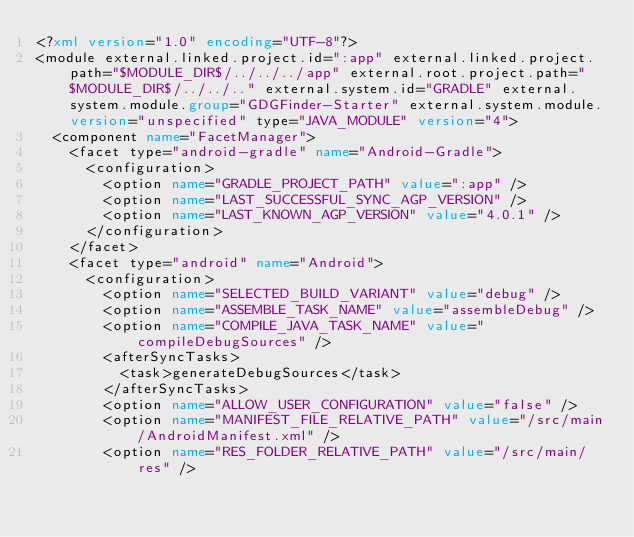<code> <loc_0><loc_0><loc_500><loc_500><_XML_><?xml version="1.0" encoding="UTF-8"?>
<module external.linked.project.id=":app" external.linked.project.path="$MODULE_DIR$/../../../app" external.root.project.path="$MODULE_DIR$/../../.." external.system.id="GRADLE" external.system.module.group="GDGFinder-Starter" external.system.module.version="unspecified" type="JAVA_MODULE" version="4">
  <component name="FacetManager">
    <facet type="android-gradle" name="Android-Gradle">
      <configuration>
        <option name="GRADLE_PROJECT_PATH" value=":app" />
        <option name="LAST_SUCCESSFUL_SYNC_AGP_VERSION" />
        <option name="LAST_KNOWN_AGP_VERSION" value="4.0.1" />
      </configuration>
    </facet>
    <facet type="android" name="Android">
      <configuration>
        <option name="SELECTED_BUILD_VARIANT" value="debug" />
        <option name="ASSEMBLE_TASK_NAME" value="assembleDebug" />
        <option name="COMPILE_JAVA_TASK_NAME" value="compileDebugSources" />
        <afterSyncTasks>
          <task>generateDebugSources</task>
        </afterSyncTasks>
        <option name="ALLOW_USER_CONFIGURATION" value="false" />
        <option name="MANIFEST_FILE_RELATIVE_PATH" value="/src/main/AndroidManifest.xml" />
        <option name="RES_FOLDER_RELATIVE_PATH" value="/src/main/res" /></code> 